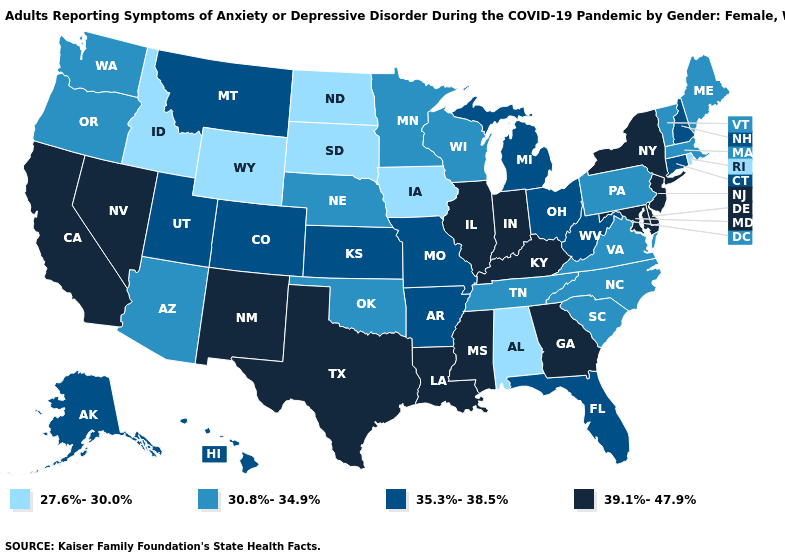What is the value of North Dakota?
Give a very brief answer. 27.6%-30.0%. What is the value of Wisconsin?
Answer briefly. 30.8%-34.9%. Among the states that border Oregon , does Idaho have the lowest value?
Write a very short answer. Yes. Is the legend a continuous bar?
Short answer required. No. What is the lowest value in states that border Iowa?
Short answer required. 27.6%-30.0%. What is the value of Arkansas?
Write a very short answer. 35.3%-38.5%. Does the first symbol in the legend represent the smallest category?
Quick response, please. Yes. Name the states that have a value in the range 27.6%-30.0%?
Write a very short answer. Alabama, Idaho, Iowa, North Dakota, Rhode Island, South Dakota, Wyoming. What is the lowest value in the South?
Be succinct. 27.6%-30.0%. What is the value of Pennsylvania?
Write a very short answer. 30.8%-34.9%. What is the value of Indiana?
Be succinct. 39.1%-47.9%. Among the states that border Arkansas , which have the lowest value?
Be succinct. Oklahoma, Tennessee. Name the states that have a value in the range 30.8%-34.9%?
Answer briefly. Arizona, Maine, Massachusetts, Minnesota, Nebraska, North Carolina, Oklahoma, Oregon, Pennsylvania, South Carolina, Tennessee, Vermont, Virginia, Washington, Wisconsin. Which states have the lowest value in the USA?
Write a very short answer. Alabama, Idaho, Iowa, North Dakota, Rhode Island, South Dakota, Wyoming. Does the map have missing data?
Write a very short answer. No. 